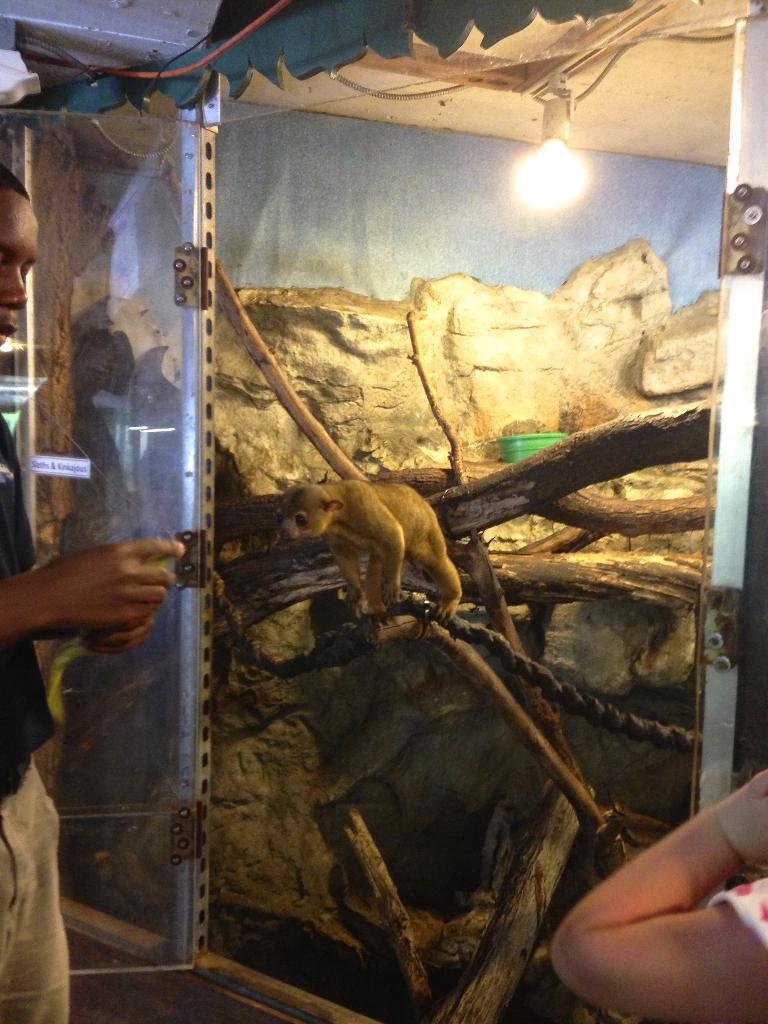How many people are in the image? There are two persons in the image. What can be seen behind the people? There is a glass door in the image. What is the animal in the image doing? The animal is standing on a branch in the image. What can be seen in the background of the image? There is light and a wall visible in the background of the image. What type of sack is being offered by the person on the left in the image? There is no sack being offered in the image, and there is only one person visible. 